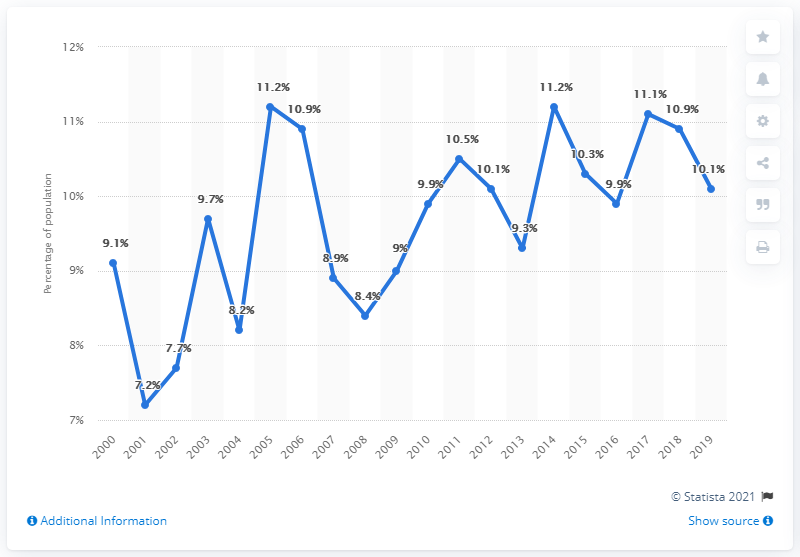Draw attention to some important aspects in this diagram. The average of 2018 and 2019 is 10.5. The chart shows the recorded values of a certain metric from various years. The lowest value recorded in the chart was in 2001. In 2019, approximately 10.1% of the population in Alaska lived below the poverty line. 